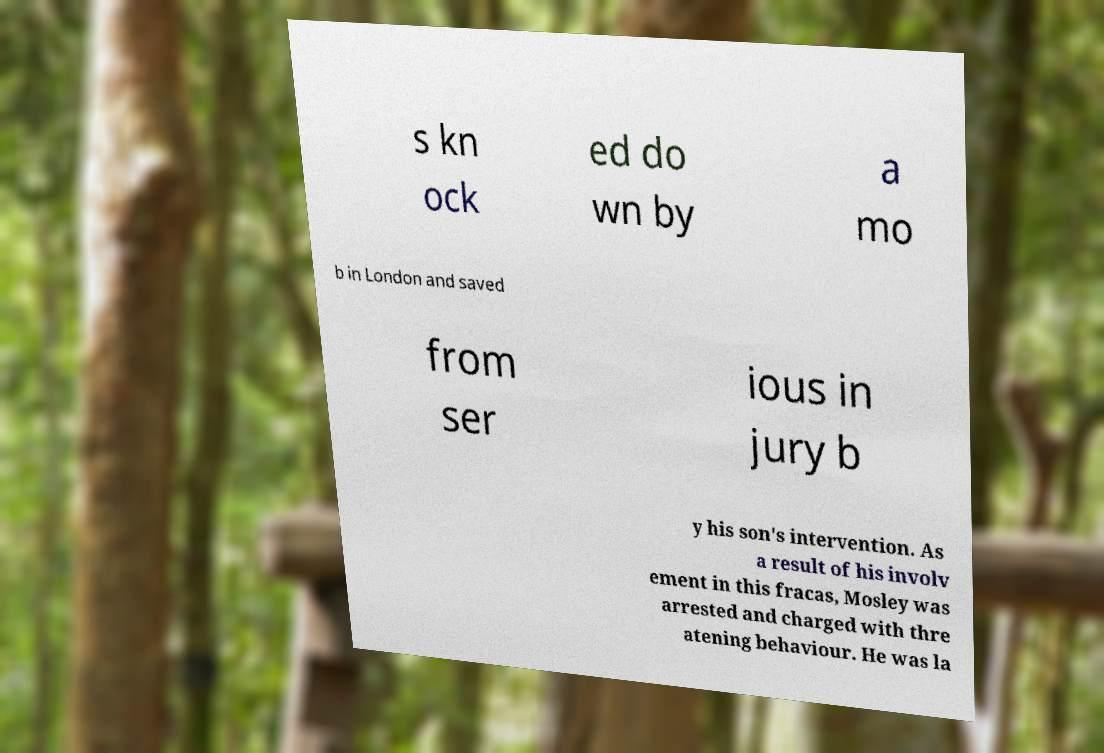I need the written content from this picture converted into text. Can you do that? s kn ock ed do wn by a mo b in London and saved from ser ious in jury b y his son's intervention. As a result of his involv ement in this fracas, Mosley was arrested and charged with thre atening behaviour. He was la 